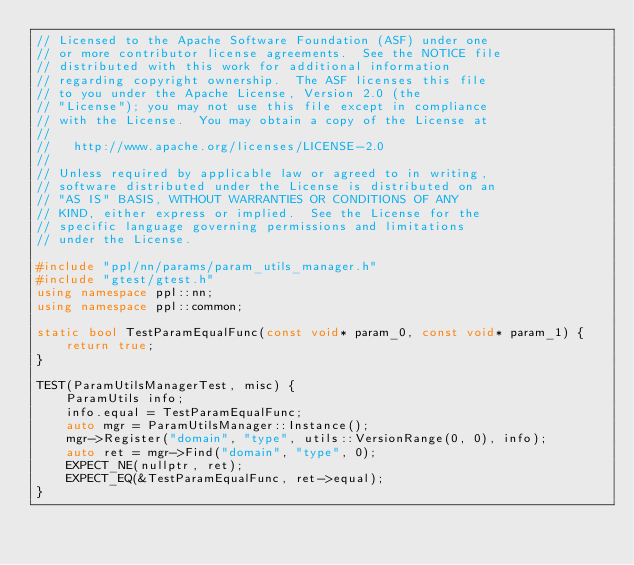Convert code to text. <code><loc_0><loc_0><loc_500><loc_500><_C++_>// Licensed to the Apache Software Foundation (ASF) under one
// or more contributor license agreements.  See the NOTICE file
// distributed with this work for additional information
// regarding copyright ownership.  The ASF licenses this file
// to you under the Apache License, Version 2.0 (the
// "License"); you may not use this file except in compliance
// with the License.  You may obtain a copy of the License at
//
//   http://www.apache.org/licenses/LICENSE-2.0
//
// Unless required by applicable law or agreed to in writing,
// software distributed under the License is distributed on an
// "AS IS" BASIS, WITHOUT WARRANTIES OR CONDITIONS OF ANY
// KIND, either express or implied.  See the License for the
// specific language governing permissions and limitations
// under the License.

#include "ppl/nn/params/param_utils_manager.h"
#include "gtest/gtest.h"
using namespace ppl::nn;
using namespace ppl::common;

static bool TestParamEqualFunc(const void* param_0, const void* param_1) {
    return true;
}

TEST(ParamUtilsManagerTest, misc) {
    ParamUtils info;
    info.equal = TestParamEqualFunc;
    auto mgr = ParamUtilsManager::Instance();
    mgr->Register("domain", "type", utils::VersionRange(0, 0), info);
    auto ret = mgr->Find("domain", "type", 0);
    EXPECT_NE(nullptr, ret);
    EXPECT_EQ(&TestParamEqualFunc, ret->equal);
}
</code> 